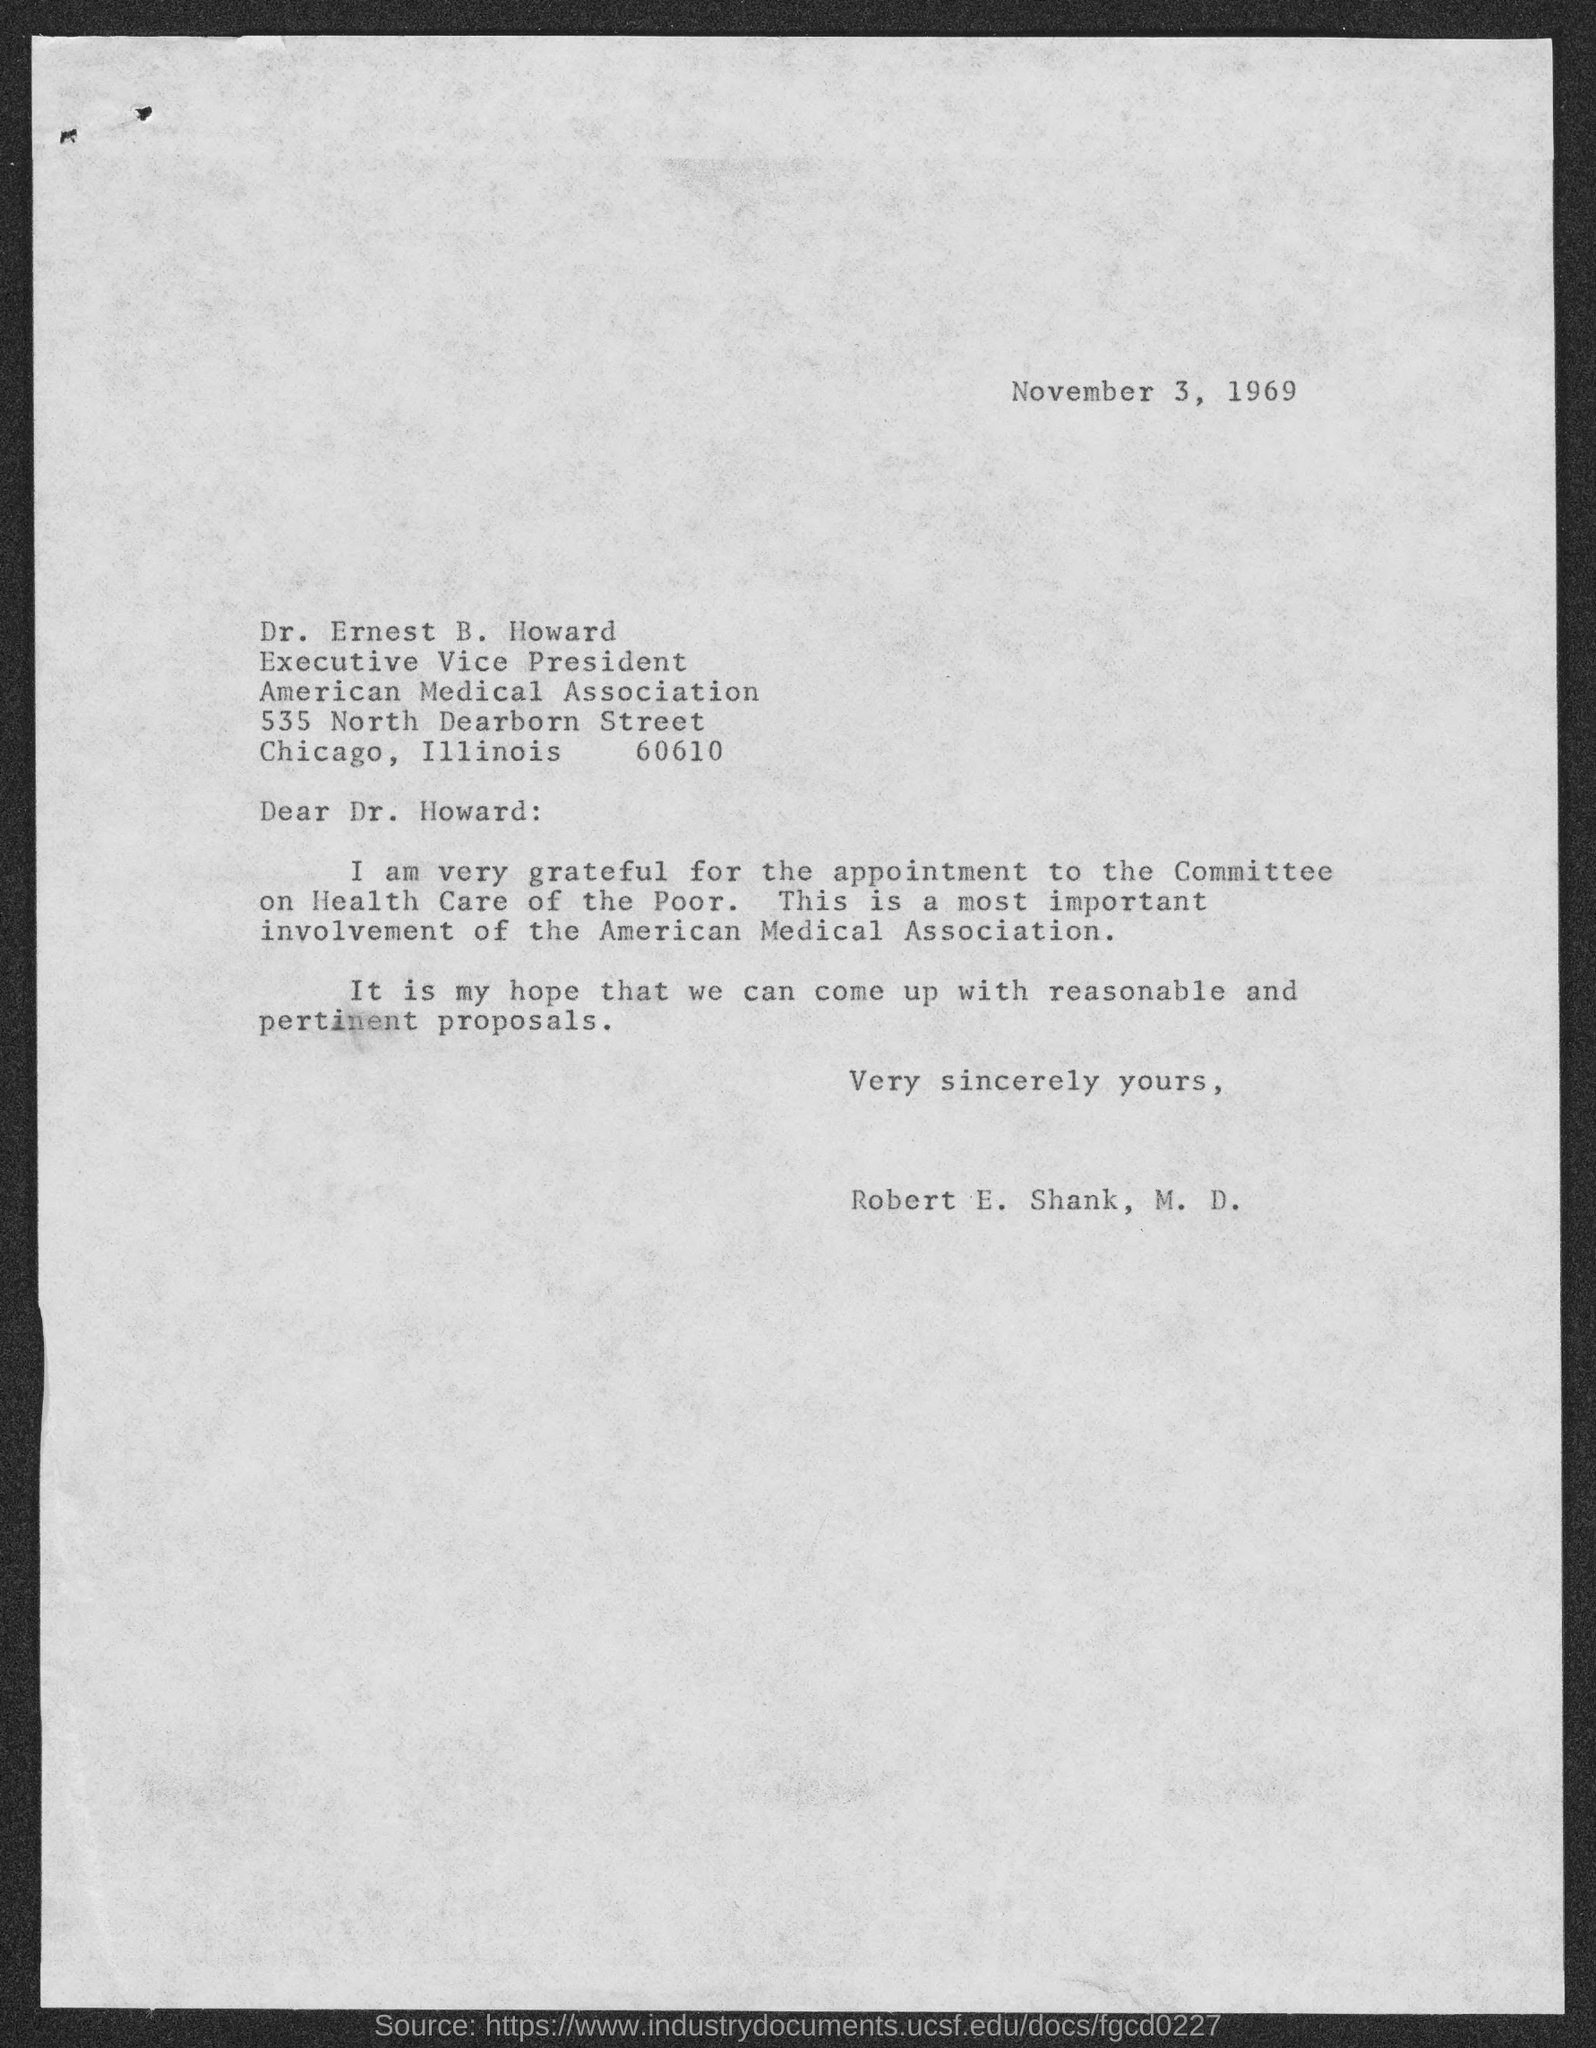On which date the letter is dated on?
Keep it short and to the point. November 3, 1969. Who is the executive vice president of american medical association?
Provide a short and direct response. Dr. Ernest B. Howard. Who wrote this letter?
Offer a terse response. Robert E. Shank, M.D. To whom this letter is written to?
Provide a succinct answer. Dr. Ernest B. Howard. 